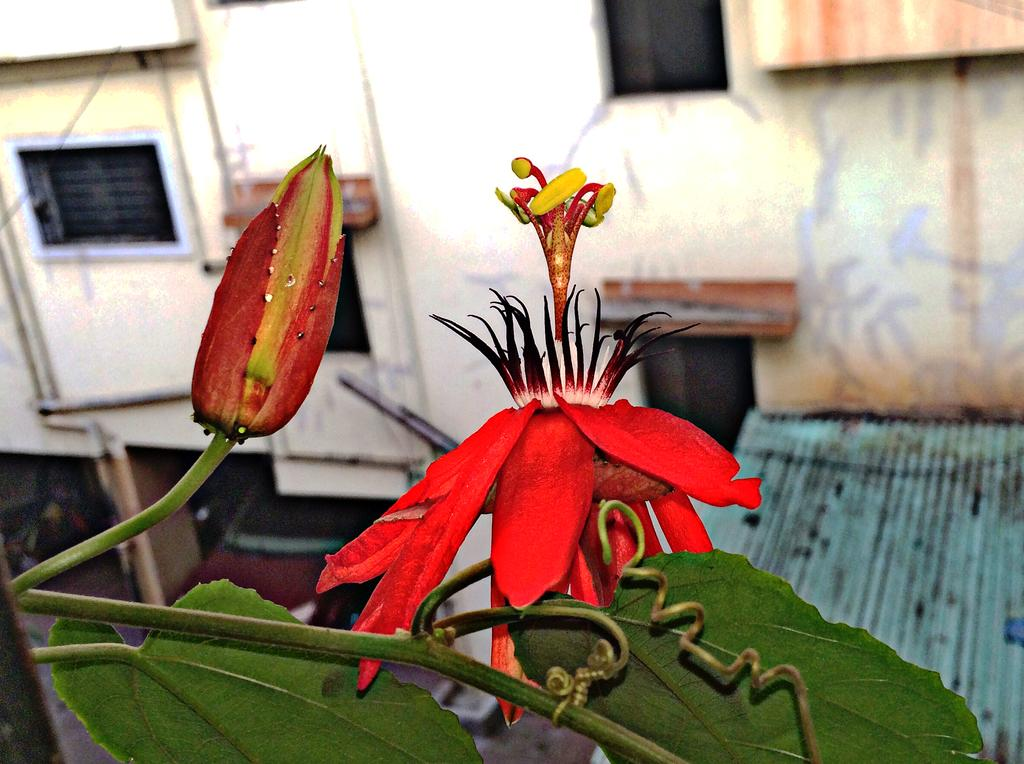What type of plant is visible on the left side of the image? There is a flower bud on the left side of the image. What color is the flower on the right side of the image? There is a red color flower on the right side of the image. What type of structure can be seen in the image? There is a building in the image. What type of bun is being sold at the market in the image? There is no market or bun present in the image; it features a flower bud, a red flower, and a building. 